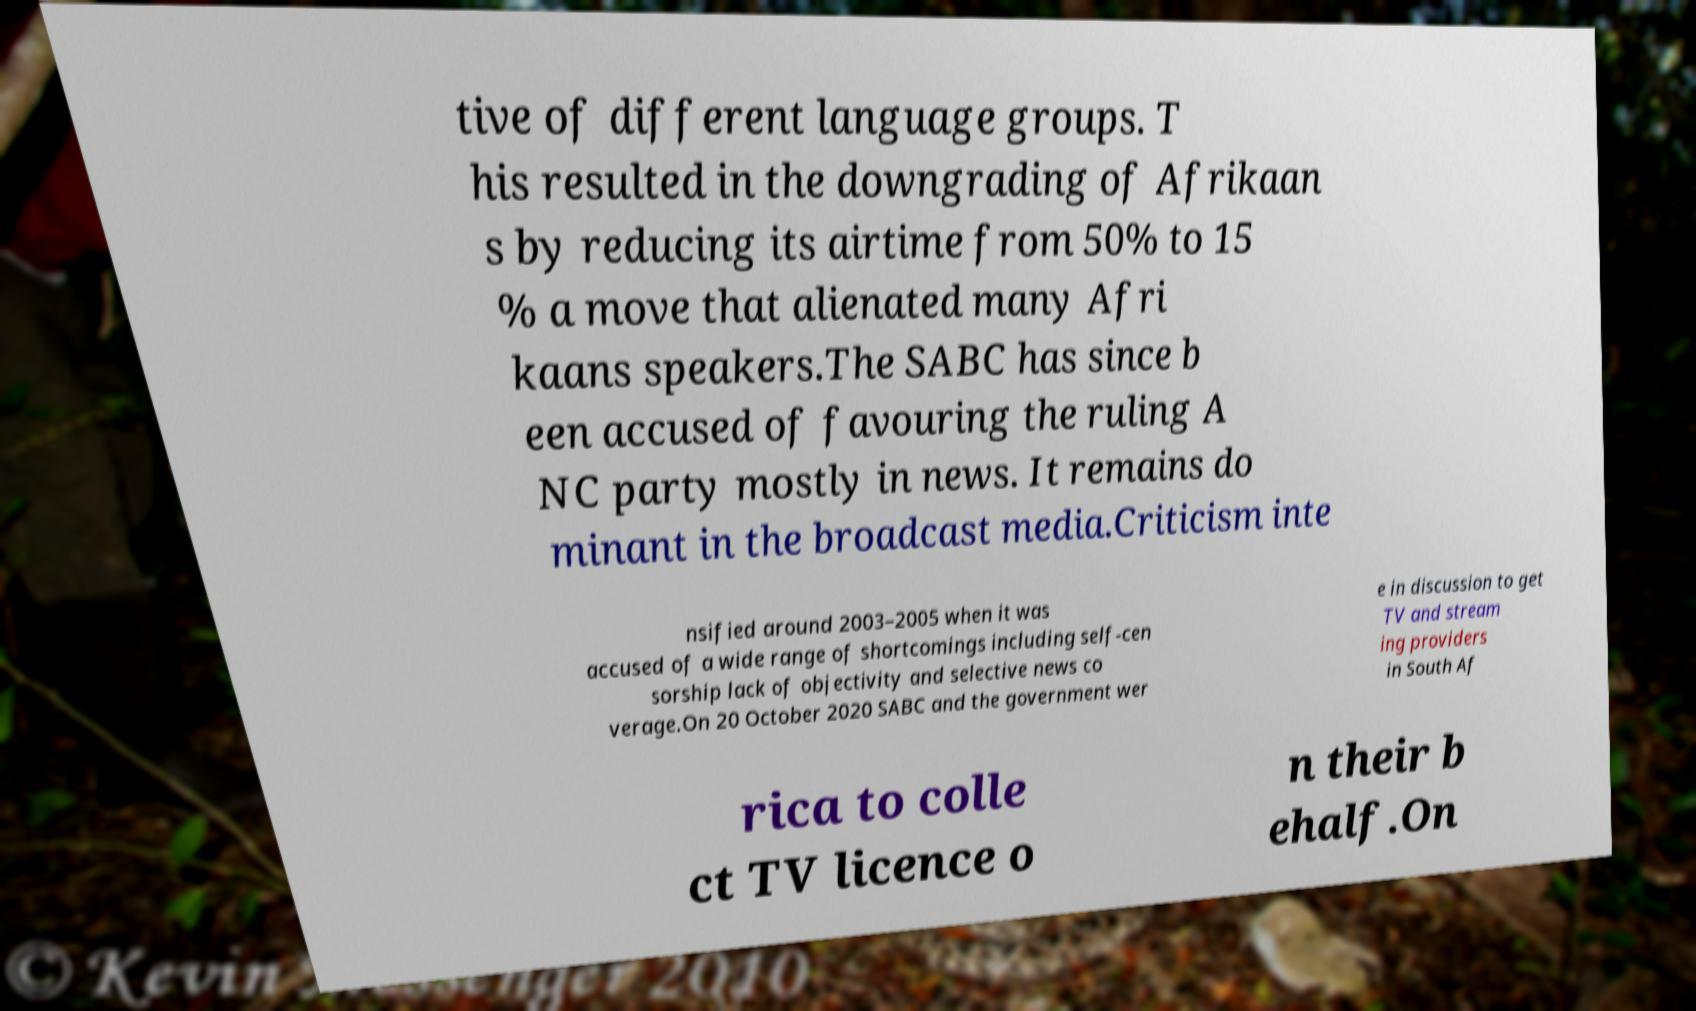What messages or text are displayed in this image? I need them in a readable, typed format. tive of different language groups. T his resulted in the downgrading of Afrikaan s by reducing its airtime from 50% to 15 % a move that alienated many Afri kaans speakers.The SABC has since b een accused of favouring the ruling A NC party mostly in news. It remains do minant in the broadcast media.Criticism inte nsified around 2003–2005 when it was accused of a wide range of shortcomings including self-cen sorship lack of objectivity and selective news co verage.On 20 October 2020 SABC and the government wer e in discussion to get TV and stream ing providers in South Af rica to colle ct TV licence o n their b ehalf.On 